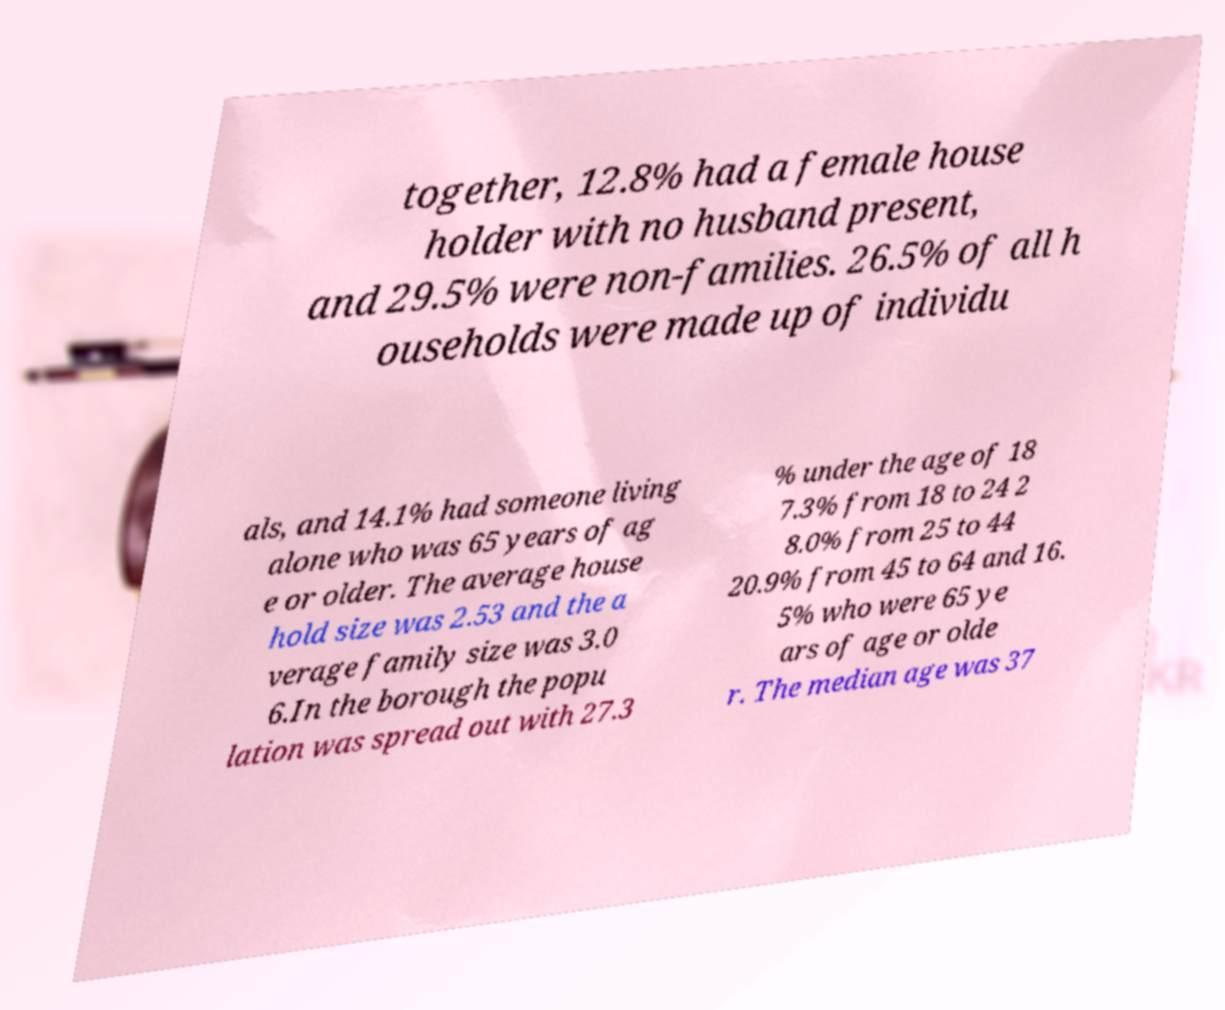There's text embedded in this image that I need extracted. Can you transcribe it verbatim? together, 12.8% had a female house holder with no husband present, and 29.5% were non-families. 26.5% of all h ouseholds were made up of individu als, and 14.1% had someone living alone who was 65 years of ag e or older. The average house hold size was 2.53 and the a verage family size was 3.0 6.In the borough the popu lation was spread out with 27.3 % under the age of 18 7.3% from 18 to 24 2 8.0% from 25 to 44 20.9% from 45 to 64 and 16. 5% who were 65 ye ars of age or olde r. The median age was 37 